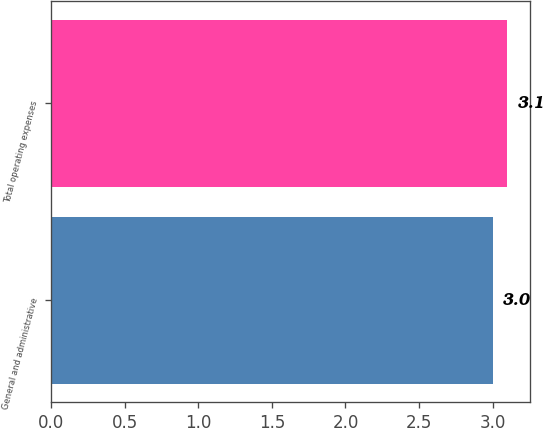Convert chart. <chart><loc_0><loc_0><loc_500><loc_500><bar_chart><fcel>General and administrative<fcel>Total operating expenses<nl><fcel>3<fcel>3.1<nl></chart> 